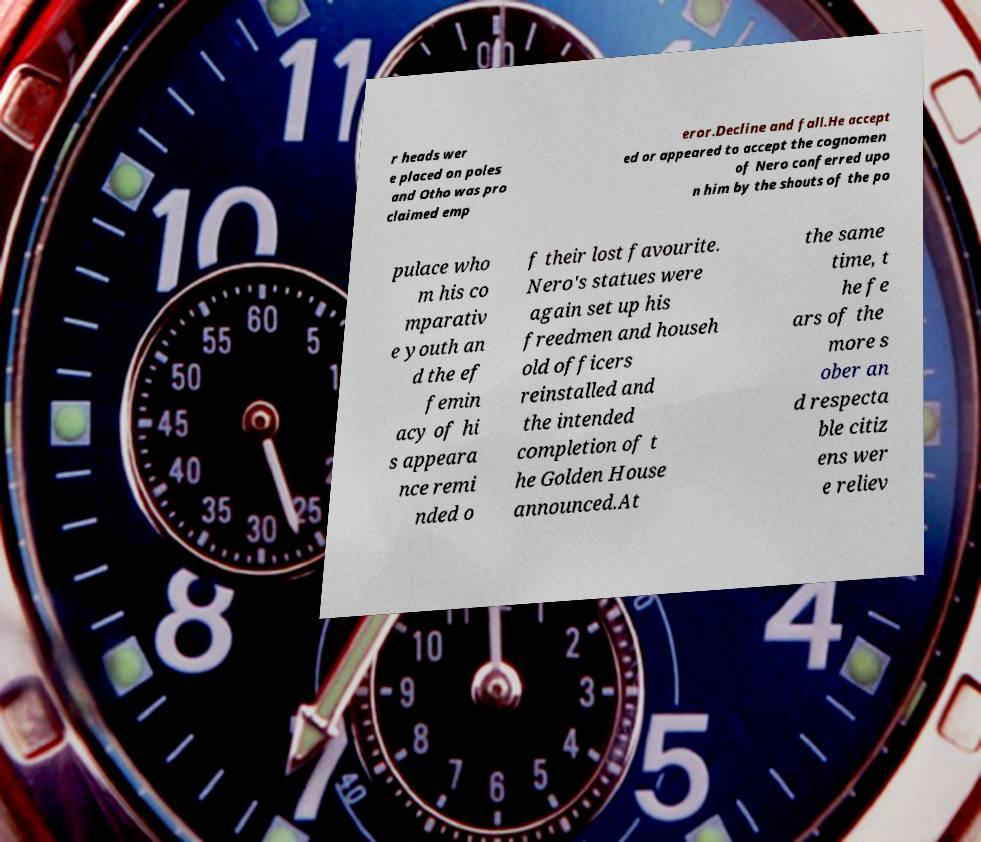Please identify and transcribe the text found in this image. r heads wer e placed on poles and Otho was pro claimed emp eror.Decline and fall.He accept ed or appeared to accept the cognomen of Nero conferred upo n him by the shouts of the po pulace who m his co mparativ e youth an d the ef femin acy of hi s appeara nce remi nded o f their lost favourite. Nero's statues were again set up his freedmen and househ old officers reinstalled and the intended completion of t he Golden House announced.At the same time, t he fe ars of the more s ober an d respecta ble citiz ens wer e reliev 